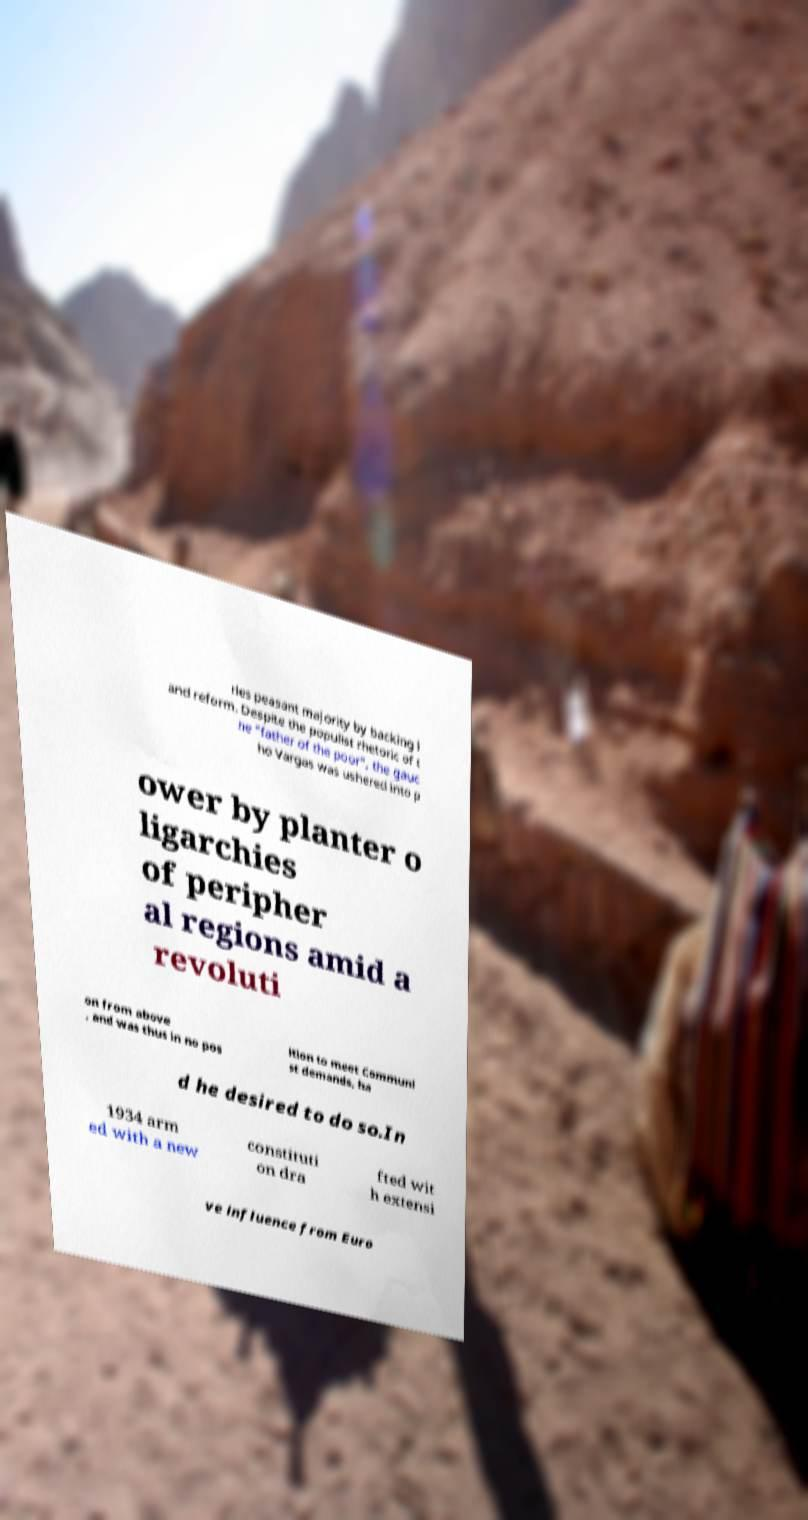Can you read and provide the text displayed in the image?This photo seems to have some interesting text. Can you extract and type it out for me? ries peasant majority by backing l and reform. Despite the populist rhetoric of t he "father of the poor", the gauc ho Vargas was ushered into p ower by planter o ligarchies of peripher al regions amid a revoluti on from above , and was thus in no pos ition to meet Communi st demands, ha d he desired to do so.In 1934 arm ed with a new constituti on dra fted wit h extensi ve influence from Euro 